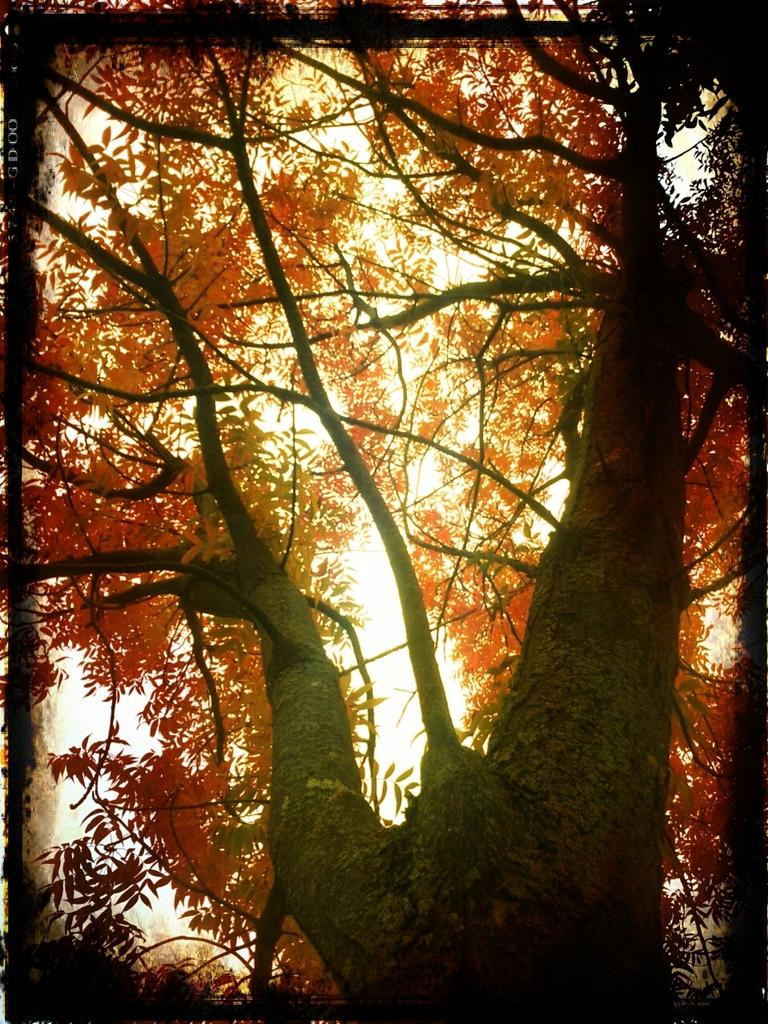What type of vegetation can be seen in the image? There is a tree in the image. What is visible in the background of the image? The sky is visible in the background of the image. Where is the pump located in the image? There is no pump present in the image. How many stars can be seen in the image? There are no stars visible in the image; only the tree and sky are present. 